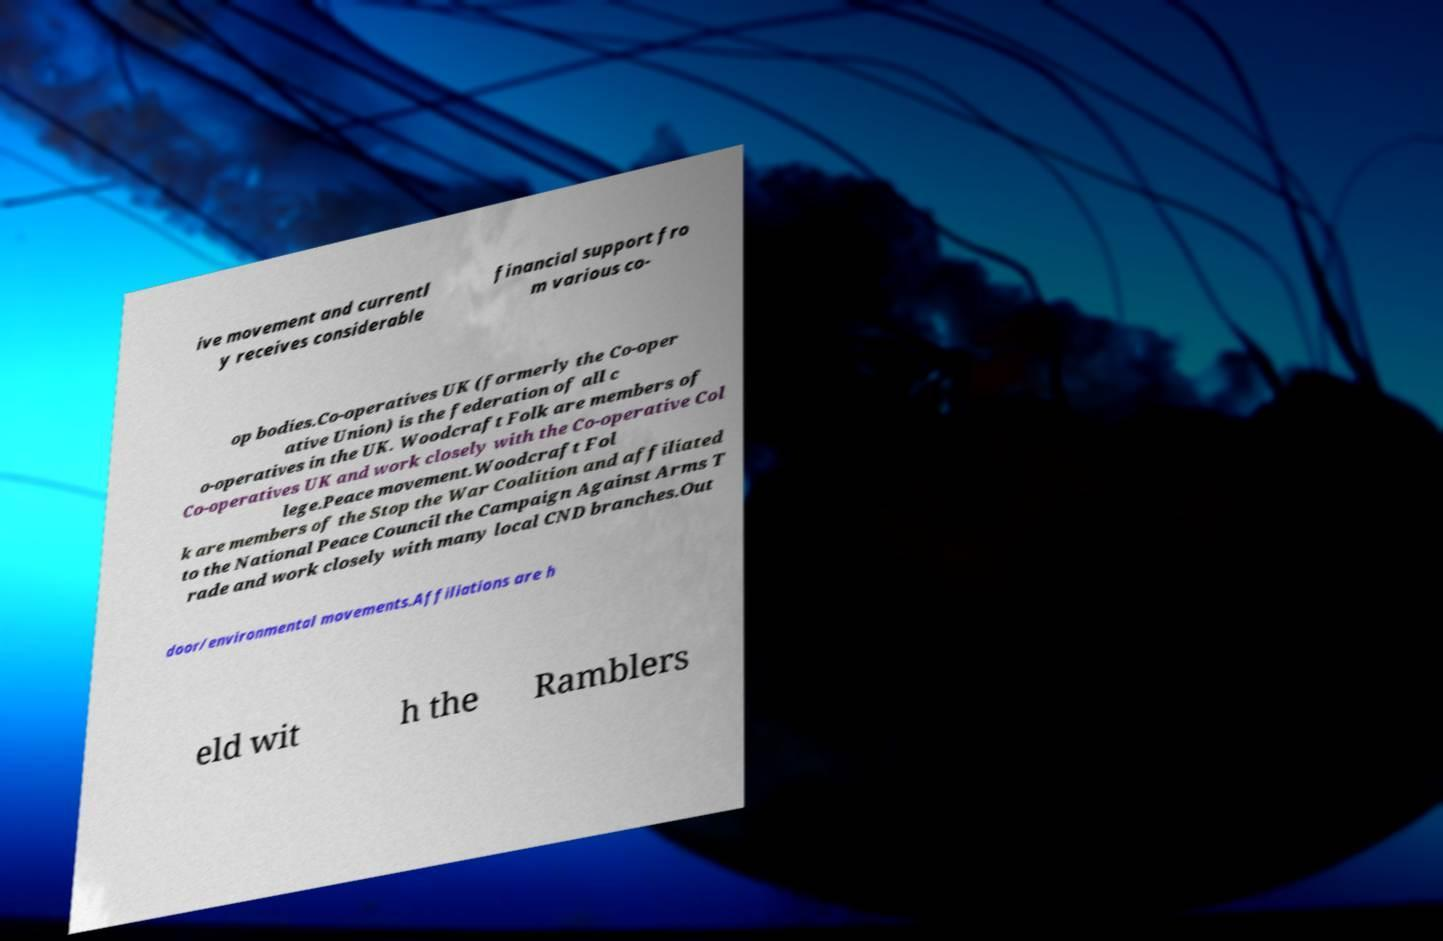Could you assist in decoding the text presented in this image and type it out clearly? ive movement and currentl y receives considerable financial support fro m various co- op bodies.Co-operatives UK (formerly the Co-oper ative Union) is the federation of all c o-operatives in the UK. Woodcraft Folk are members of Co-operatives UK and work closely with the Co-operative Col lege.Peace movement.Woodcraft Fol k are members of the Stop the War Coalition and affiliated to the National Peace Council the Campaign Against Arms T rade and work closely with many local CND branches.Out door/environmental movements.Affiliations are h eld wit h the Ramblers 